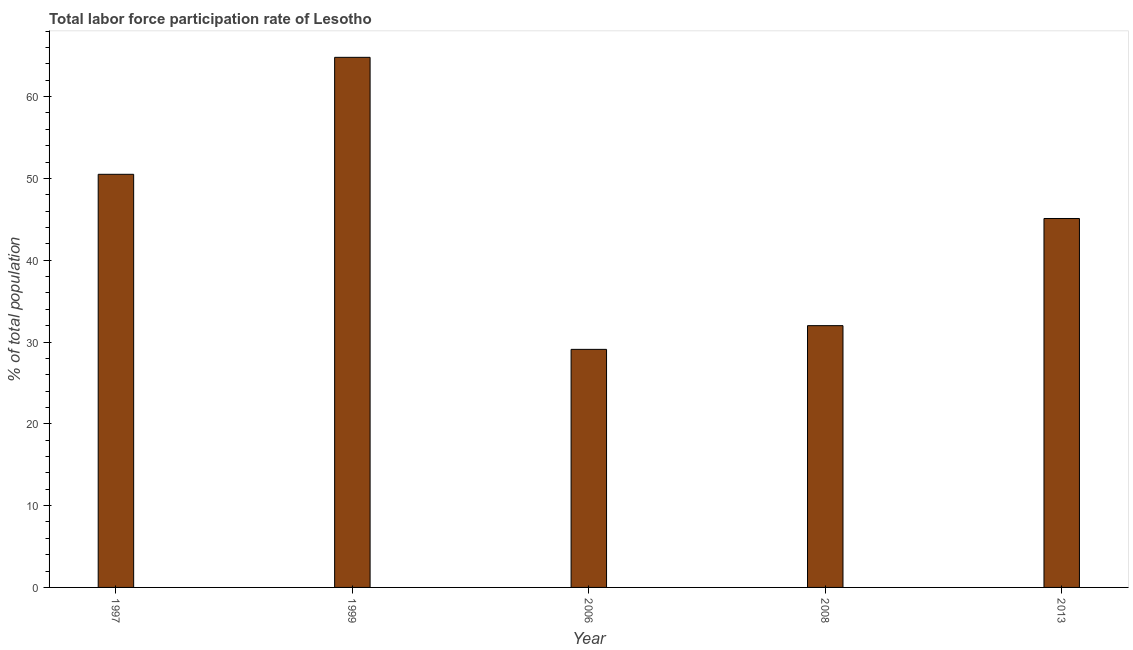What is the title of the graph?
Keep it short and to the point. Total labor force participation rate of Lesotho. What is the label or title of the X-axis?
Your response must be concise. Year. What is the label or title of the Y-axis?
Ensure brevity in your answer.  % of total population. What is the total labor force participation rate in 2006?
Provide a short and direct response. 29.1. Across all years, what is the maximum total labor force participation rate?
Offer a terse response. 64.8. Across all years, what is the minimum total labor force participation rate?
Your response must be concise. 29.1. In which year was the total labor force participation rate maximum?
Give a very brief answer. 1999. In which year was the total labor force participation rate minimum?
Make the answer very short. 2006. What is the sum of the total labor force participation rate?
Make the answer very short. 221.5. What is the difference between the total labor force participation rate in 2006 and 2008?
Give a very brief answer. -2.9. What is the average total labor force participation rate per year?
Give a very brief answer. 44.3. What is the median total labor force participation rate?
Provide a short and direct response. 45.1. What is the ratio of the total labor force participation rate in 1999 to that in 2013?
Your response must be concise. 1.44. Is the difference between the total labor force participation rate in 1997 and 2006 greater than the difference between any two years?
Offer a very short reply. No. What is the difference between the highest and the lowest total labor force participation rate?
Make the answer very short. 35.7. How many bars are there?
Offer a very short reply. 5. Are all the bars in the graph horizontal?
Offer a very short reply. No. How many years are there in the graph?
Your answer should be very brief. 5. Are the values on the major ticks of Y-axis written in scientific E-notation?
Offer a terse response. No. What is the % of total population of 1997?
Keep it short and to the point. 50.5. What is the % of total population in 1999?
Your answer should be very brief. 64.8. What is the % of total population in 2006?
Your answer should be compact. 29.1. What is the % of total population of 2008?
Your answer should be compact. 32. What is the % of total population of 2013?
Your answer should be very brief. 45.1. What is the difference between the % of total population in 1997 and 1999?
Provide a succinct answer. -14.3. What is the difference between the % of total population in 1997 and 2006?
Ensure brevity in your answer.  21.4. What is the difference between the % of total population in 1999 and 2006?
Make the answer very short. 35.7. What is the difference between the % of total population in 1999 and 2008?
Ensure brevity in your answer.  32.8. What is the difference between the % of total population in 1999 and 2013?
Your response must be concise. 19.7. What is the difference between the % of total population in 2006 and 2008?
Offer a very short reply. -2.9. What is the ratio of the % of total population in 1997 to that in 1999?
Ensure brevity in your answer.  0.78. What is the ratio of the % of total population in 1997 to that in 2006?
Keep it short and to the point. 1.74. What is the ratio of the % of total population in 1997 to that in 2008?
Provide a short and direct response. 1.58. What is the ratio of the % of total population in 1997 to that in 2013?
Your answer should be compact. 1.12. What is the ratio of the % of total population in 1999 to that in 2006?
Give a very brief answer. 2.23. What is the ratio of the % of total population in 1999 to that in 2008?
Ensure brevity in your answer.  2.02. What is the ratio of the % of total population in 1999 to that in 2013?
Offer a terse response. 1.44. What is the ratio of the % of total population in 2006 to that in 2008?
Offer a terse response. 0.91. What is the ratio of the % of total population in 2006 to that in 2013?
Keep it short and to the point. 0.65. What is the ratio of the % of total population in 2008 to that in 2013?
Ensure brevity in your answer.  0.71. 